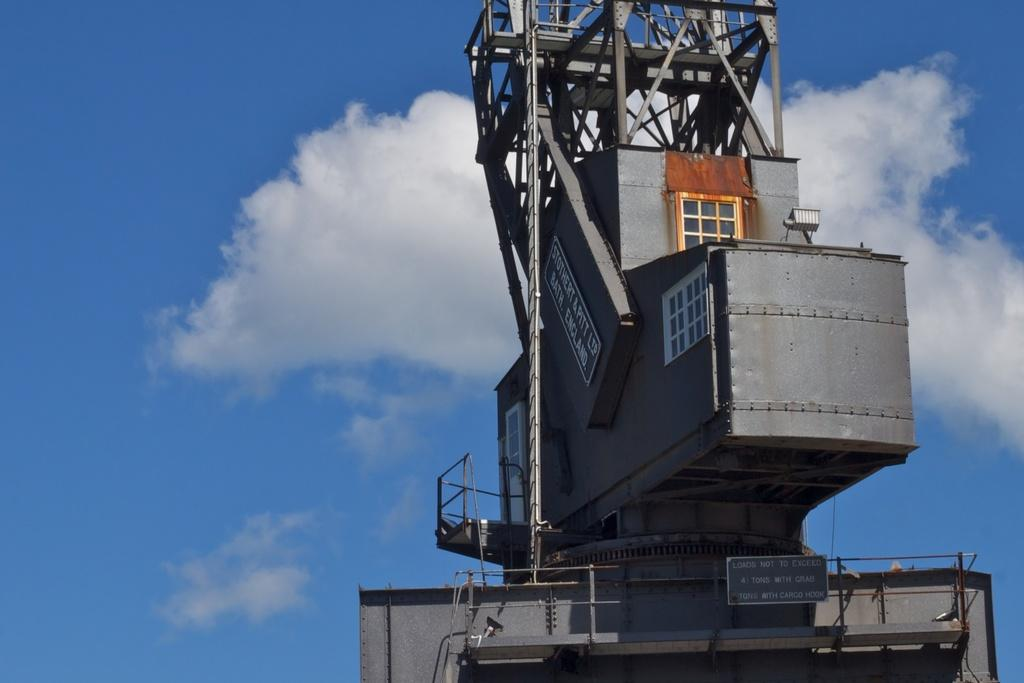What is the color of the main object in the image? The main object in the image is grey. What is attached to the grey object? Boards are attached to the grey object. What can be seen in the background of the image? There are clouds and a blue sky visible in the background. How does the grey object help with digestion in the image? The grey object does not have any relation to digestion in the image. 